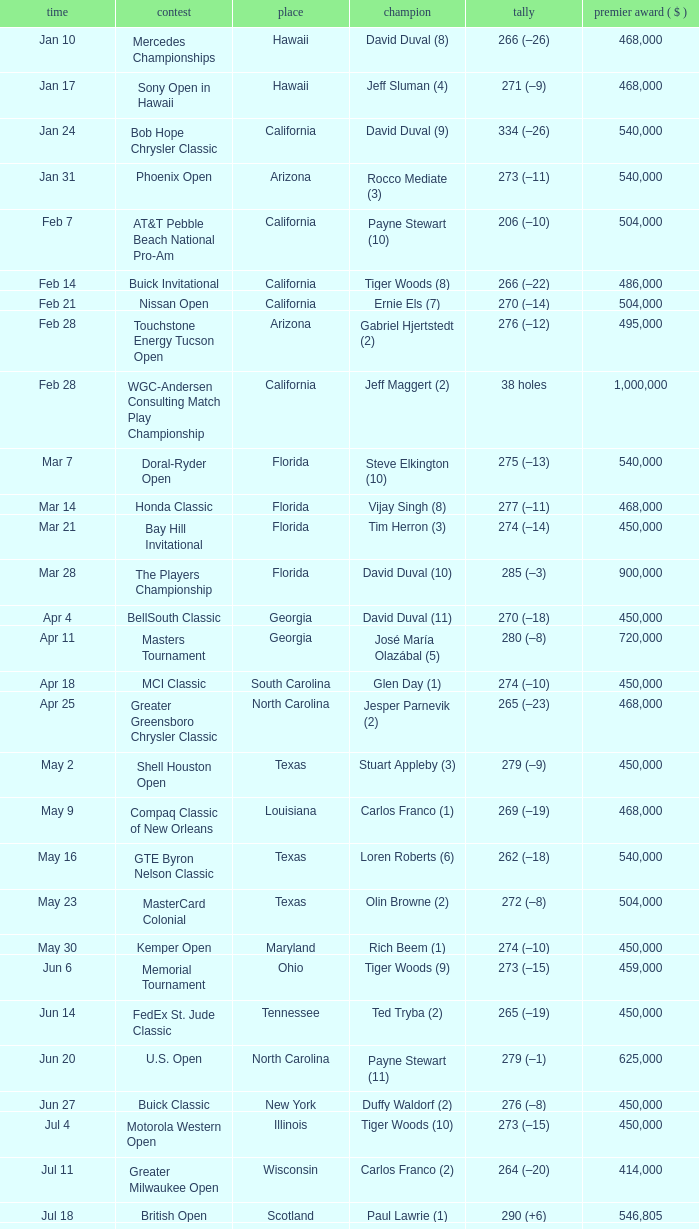What is the score of the B.C. Open in New York? 273 (–15). 